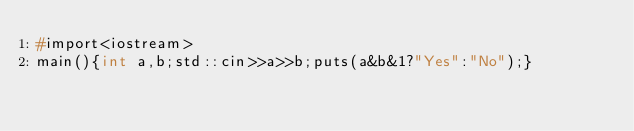Convert code to text. <code><loc_0><loc_0><loc_500><loc_500><_C++_>#import<iostream>
main(){int a,b;std::cin>>a>>b;puts(a&b&1?"Yes":"No");}</code> 